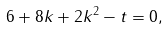<formula> <loc_0><loc_0><loc_500><loc_500>& 6 + 8 k + 2 k ^ { 2 } - t = 0 ,</formula> 